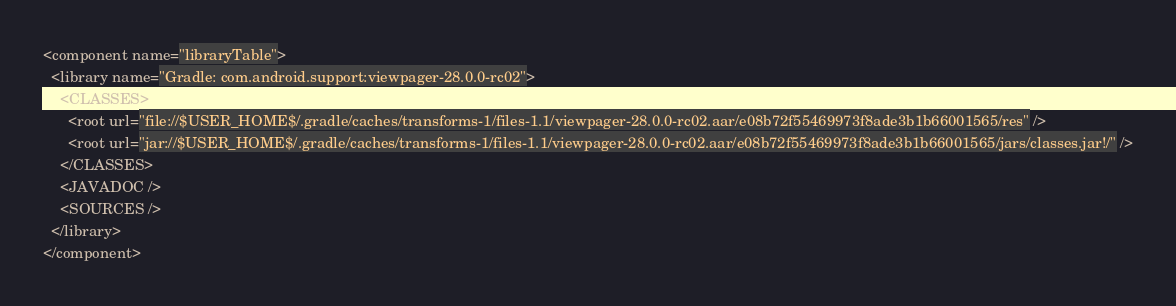Convert code to text. <code><loc_0><loc_0><loc_500><loc_500><_XML_><component name="libraryTable">
  <library name="Gradle: com.android.support:viewpager-28.0.0-rc02">
    <CLASSES>
      <root url="file://$USER_HOME$/.gradle/caches/transforms-1/files-1.1/viewpager-28.0.0-rc02.aar/e08b72f55469973f8ade3b1b66001565/res" />
      <root url="jar://$USER_HOME$/.gradle/caches/transforms-1/files-1.1/viewpager-28.0.0-rc02.aar/e08b72f55469973f8ade3b1b66001565/jars/classes.jar!/" />
    </CLASSES>
    <JAVADOC />
    <SOURCES />
  </library>
</component></code> 